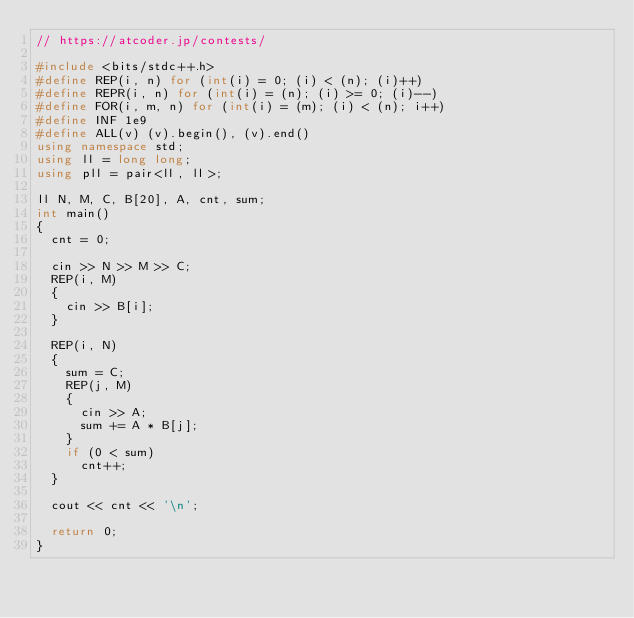Convert code to text. <code><loc_0><loc_0><loc_500><loc_500><_C++_>// https://atcoder.jp/contests/

#include <bits/stdc++.h>
#define REP(i, n) for (int(i) = 0; (i) < (n); (i)++)
#define REPR(i, n) for (int(i) = (n); (i) >= 0; (i)--)
#define FOR(i, m, n) for (int(i) = (m); (i) < (n); i++)
#define INF 1e9
#define ALL(v) (v).begin(), (v).end()
using namespace std;
using ll = long long;
using pll = pair<ll, ll>;

ll N, M, C, B[20], A, cnt, sum;
int main()
{
  cnt = 0;

  cin >> N >> M >> C;
  REP(i, M)
  {
    cin >> B[i];
  }

  REP(i, N)
  {
    sum = C;
    REP(j, M)
    {
      cin >> A;
      sum += A * B[j];
    }
    if (0 < sum)
      cnt++;
  }

  cout << cnt << '\n';

  return 0;
}
</code> 